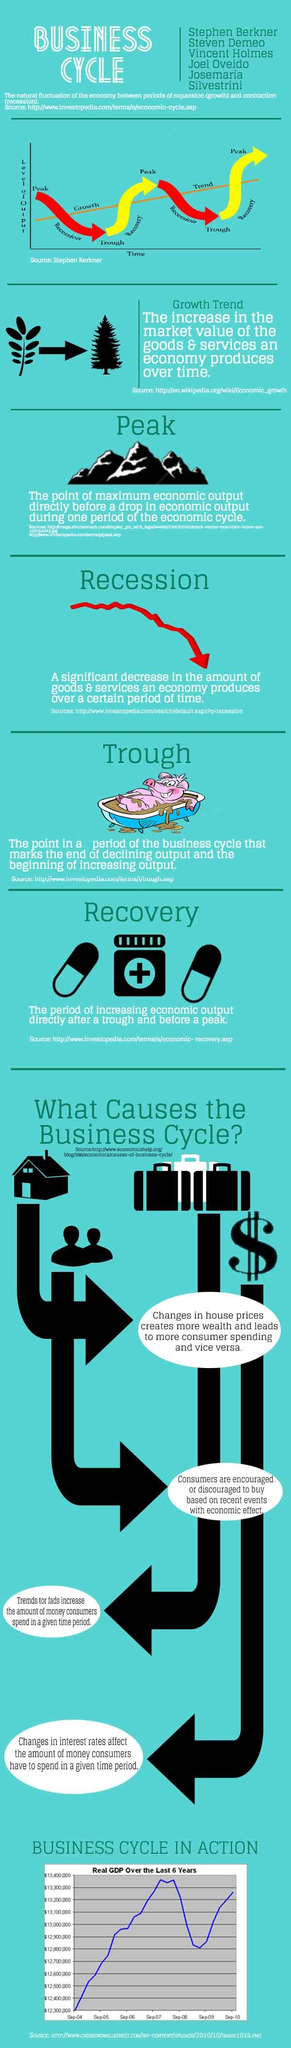Mention a couple of crucial points in this snapshot. The color red is commonly used to represent recession in graphs. In the graph, recovery is represented by the color yellow. There are two tablets under the heading 'Recovery'. 